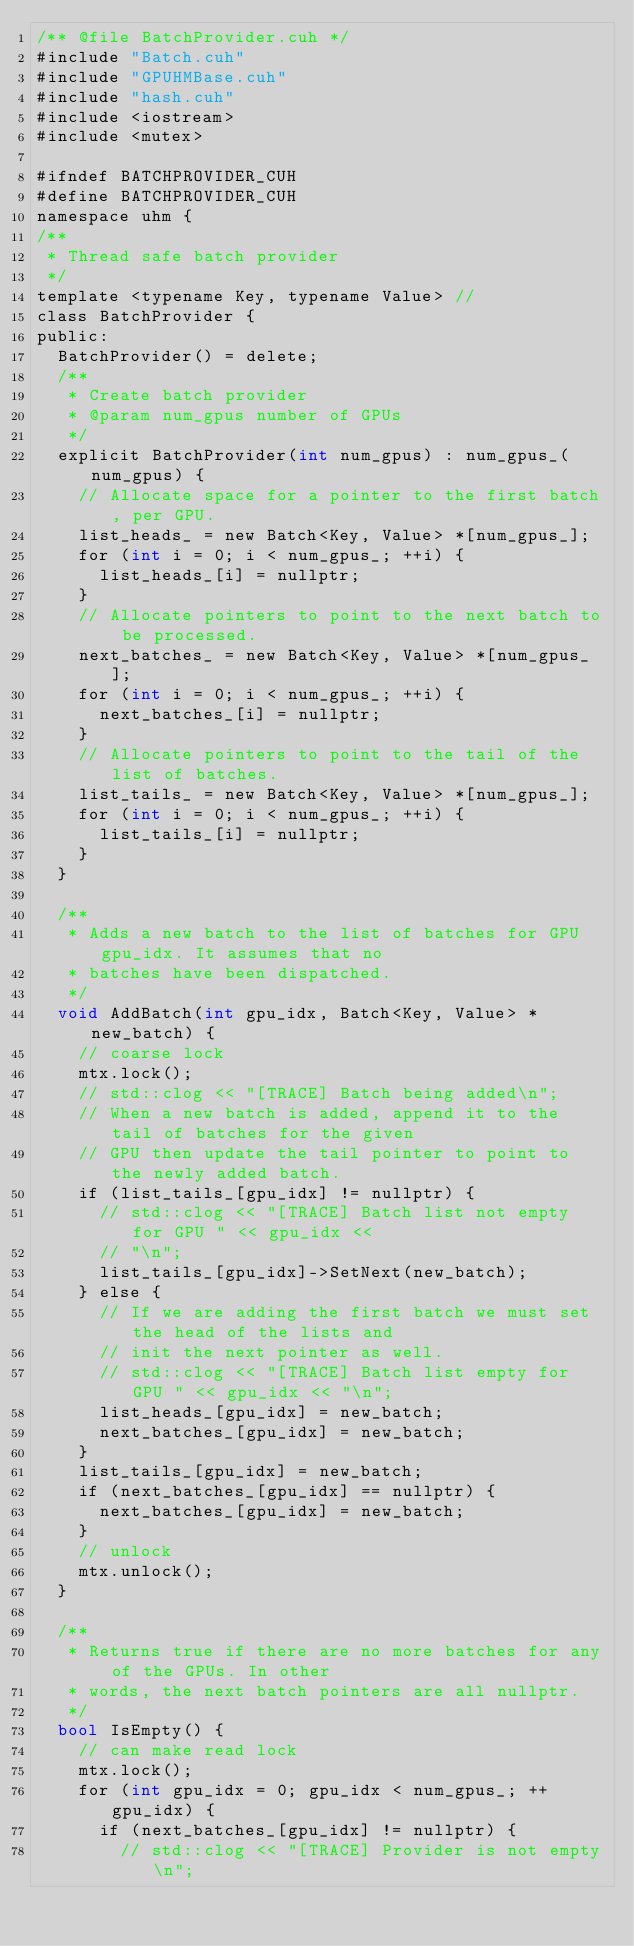Convert code to text. <code><loc_0><loc_0><loc_500><loc_500><_Cuda_>/** @file BatchProvider.cuh */
#include "Batch.cuh"
#include "GPUHMBase.cuh"
#include "hash.cuh"
#include <iostream>
#include <mutex>

#ifndef BATCHPROVIDER_CUH
#define BATCHPROVIDER_CUH
namespace uhm {
/**
 * Thread safe batch provider
 */
template <typename Key, typename Value> //
class BatchProvider {
public:
  BatchProvider() = delete;
  /**
   * Create batch provider
   * @param num_gpus number of GPUs
   */
  explicit BatchProvider(int num_gpus) : num_gpus_(num_gpus) {
    // Allocate space for a pointer to the first batch, per GPU.
    list_heads_ = new Batch<Key, Value> *[num_gpus_];
    for (int i = 0; i < num_gpus_; ++i) {
      list_heads_[i] = nullptr;
    }
    // Allocate pointers to point to the next batch to be processed.
    next_batches_ = new Batch<Key, Value> *[num_gpus_];
    for (int i = 0; i < num_gpus_; ++i) {
      next_batches_[i] = nullptr;
    }
    // Allocate pointers to point to the tail of the list of batches.
    list_tails_ = new Batch<Key, Value> *[num_gpus_];
    for (int i = 0; i < num_gpus_; ++i) {
      list_tails_[i] = nullptr;
    }
  }

  /**
   * Adds a new batch to the list of batches for GPU gpu_idx. It assumes that no
   * batches have been dispatched.
   */
  void AddBatch(int gpu_idx, Batch<Key, Value> *new_batch) {
    // coarse lock
    mtx.lock();
    // std::clog << "[TRACE] Batch being added\n";
    // When a new batch is added, append it to the tail of batches for the given
    // GPU then update the tail pointer to point to the newly added batch.
    if (list_tails_[gpu_idx] != nullptr) {
      // std::clog << "[TRACE] Batch list not empty for GPU " << gpu_idx <<
      // "\n";
      list_tails_[gpu_idx]->SetNext(new_batch);
    } else {
      // If we are adding the first batch we must set the head of the lists and
      // init the next pointer as well.
      // std::clog << "[TRACE] Batch list empty for GPU " << gpu_idx << "\n";
      list_heads_[gpu_idx] = new_batch;
      next_batches_[gpu_idx] = new_batch;
    }
    list_tails_[gpu_idx] = new_batch;
    if (next_batches_[gpu_idx] == nullptr) {
      next_batches_[gpu_idx] = new_batch;
    }
    // unlock
    mtx.unlock();
  }

  /**
   * Returns true if there are no more batches for any of the GPUs. In other
   * words, the next batch pointers are all nullptr.
   */
  bool IsEmpty() {
    // can make read lock
    mtx.lock();
    for (int gpu_idx = 0; gpu_idx < num_gpus_; ++gpu_idx) {
      if (next_batches_[gpu_idx] != nullptr) {
        // std::clog << "[TRACE] Provider is not empty\n";</code> 